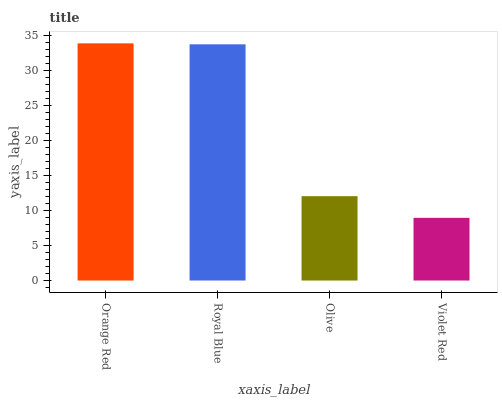Is Violet Red the minimum?
Answer yes or no. Yes. Is Orange Red the maximum?
Answer yes or no. Yes. Is Royal Blue the minimum?
Answer yes or no. No. Is Royal Blue the maximum?
Answer yes or no. No. Is Orange Red greater than Royal Blue?
Answer yes or no. Yes. Is Royal Blue less than Orange Red?
Answer yes or no. Yes. Is Royal Blue greater than Orange Red?
Answer yes or no. No. Is Orange Red less than Royal Blue?
Answer yes or no. No. Is Royal Blue the high median?
Answer yes or no. Yes. Is Olive the low median?
Answer yes or no. Yes. Is Violet Red the high median?
Answer yes or no. No. Is Royal Blue the low median?
Answer yes or no. No. 